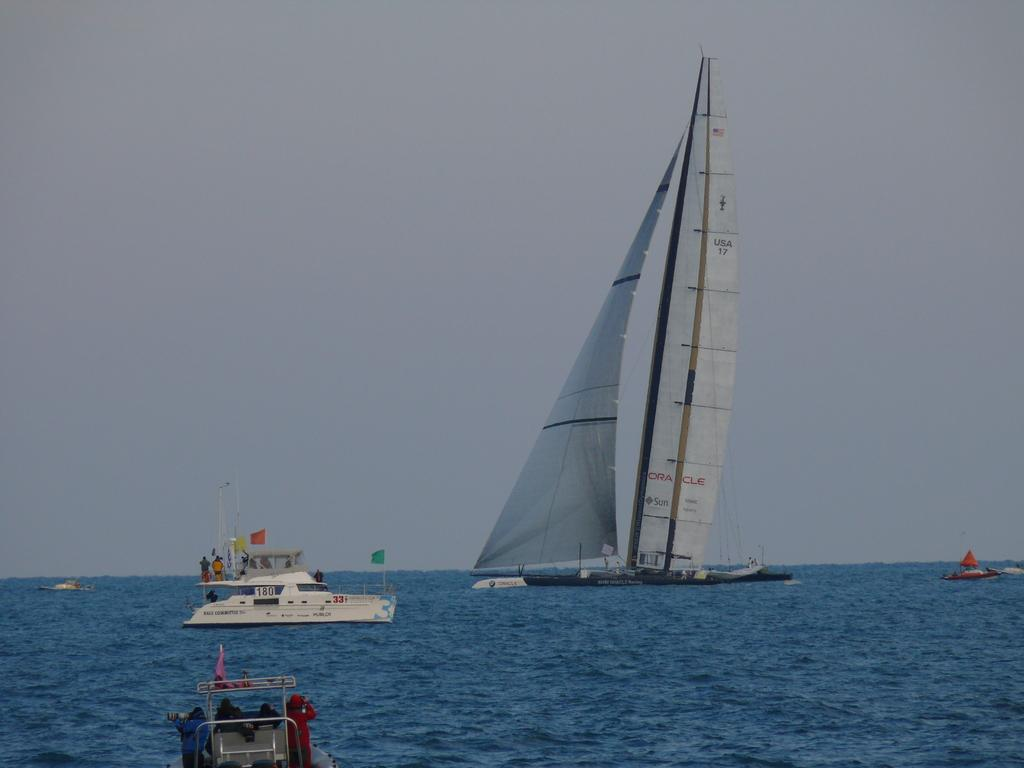What is the main subject of the image? The main subject of the image is ships. Where are the ships located? The ships are on the water. Are there any people on the ships? Yes, there are persons on the ships. What can be seen on the ships? There are flagpoles on the ships. What is visible in the background of the image? The sky is visible in the background of the image. What type of beam can be seen supporting the library in the image? There is no library or beam present in the image; it features ships on the water. How many feet are visible on the ships in the image? There are no feet visible in the image; it only shows ships, water, and people. 